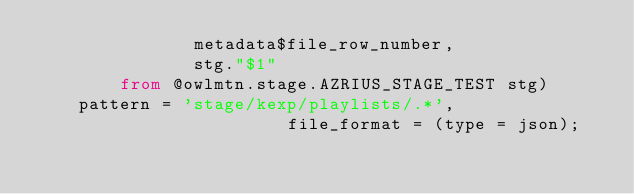Convert code to text. <code><loc_0><loc_0><loc_500><loc_500><_SQL_>               metadata$file_row_number,
               stg."$1"
        from @owlmtn.stage.AZRIUS_STAGE_TEST stg)
    pattern = 'stage/kexp/playlists/.*',
                        file_format = (type = json);

</code> 